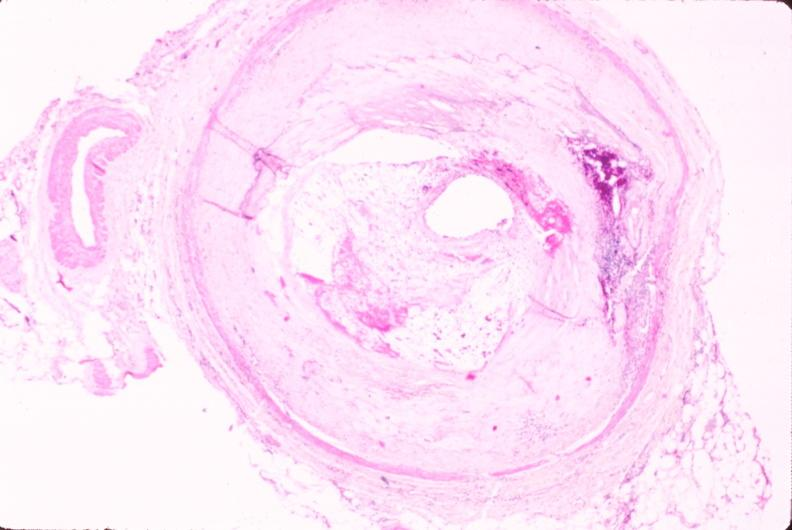s cardiovascular present?
Answer the question using a single word or phrase. Yes 